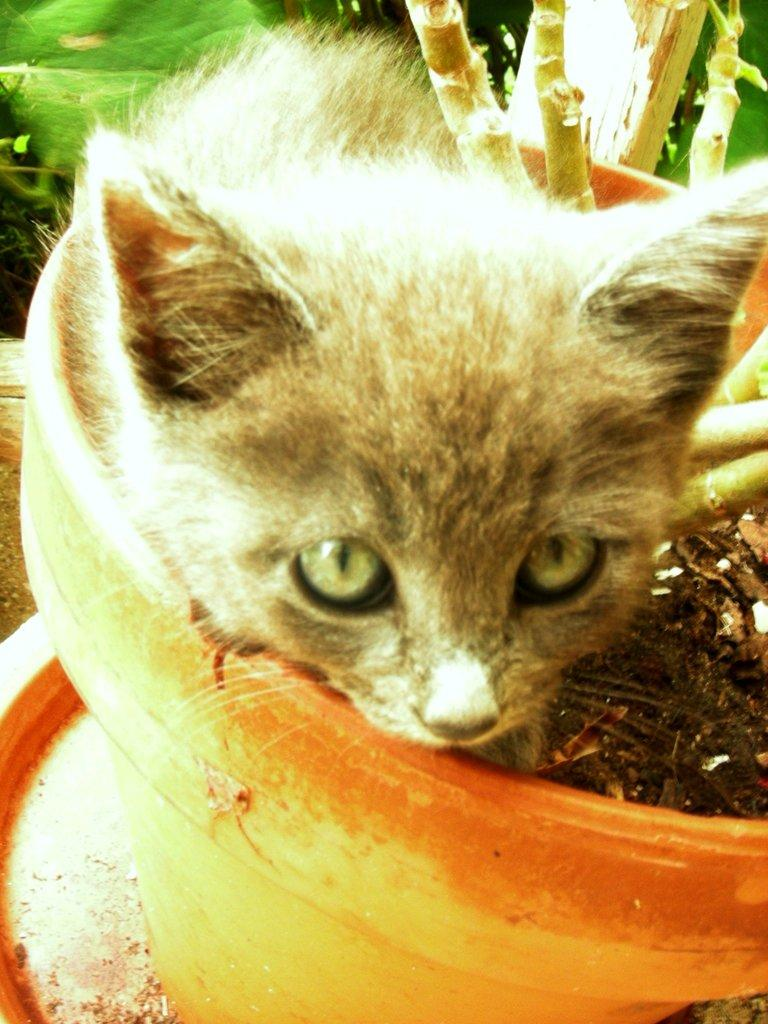What type of animal is in the image? There is a cat in the image. Where is the cat located? The cat is in a pot. What else can be seen in the image besides the cat? There are stems visible in the image. What is the color of the background in the image? The background of the image is green in color. What type of can is visible in the image? There is no can present in the image. Is there a gun visible in the image? No, there is no gun present in the image. 